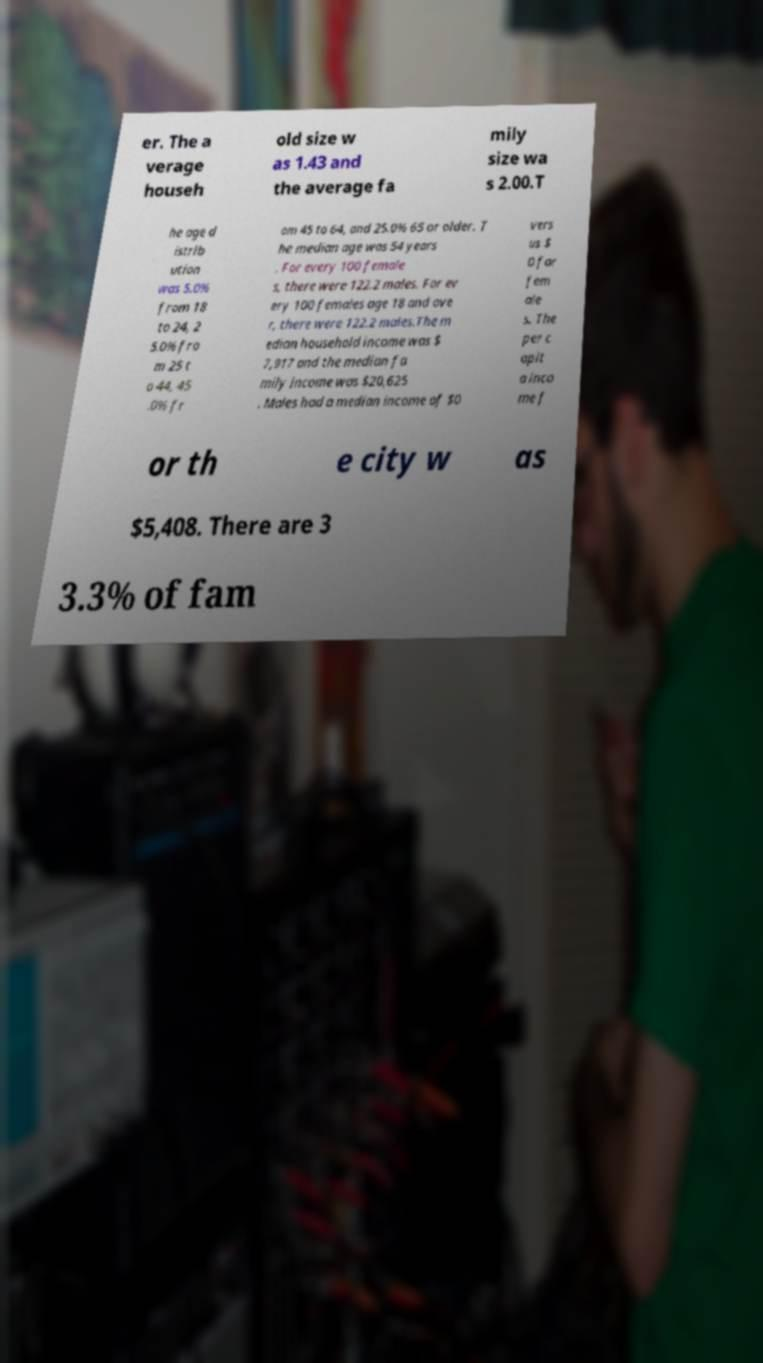Could you extract and type out the text from this image? er. The a verage househ old size w as 1.43 and the average fa mily size wa s 2.00.T he age d istrib ution was 5.0% from 18 to 24, 2 5.0% fro m 25 t o 44, 45 .0% fr om 45 to 64, and 25.0% 65 or older. T he median age was 54 years . For every 100 female s, there were 122.2 males. For ev ery 100 females age 18 and ove r, there were 122.2 males.The m edian household income was $ 7,917 and the median fa mily income was $20,625 . Males had a median income of $0 vers us $ 0 for fem ale s. The per c apit a inco me f or th e city w as $5,408. There are 3 3.3% of fam 